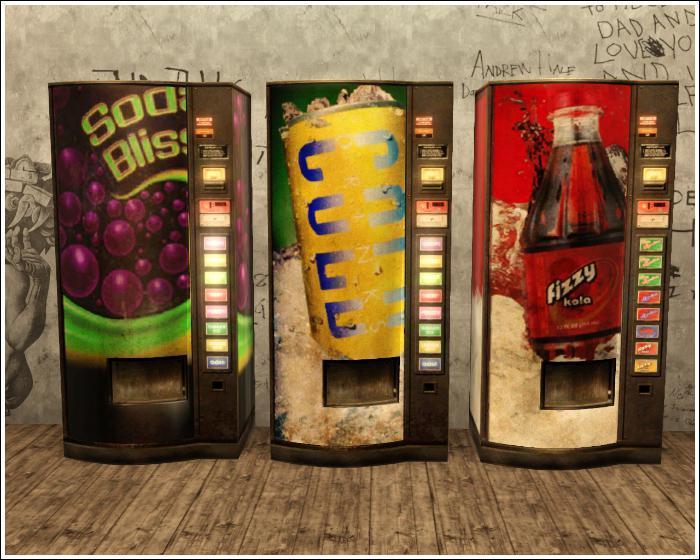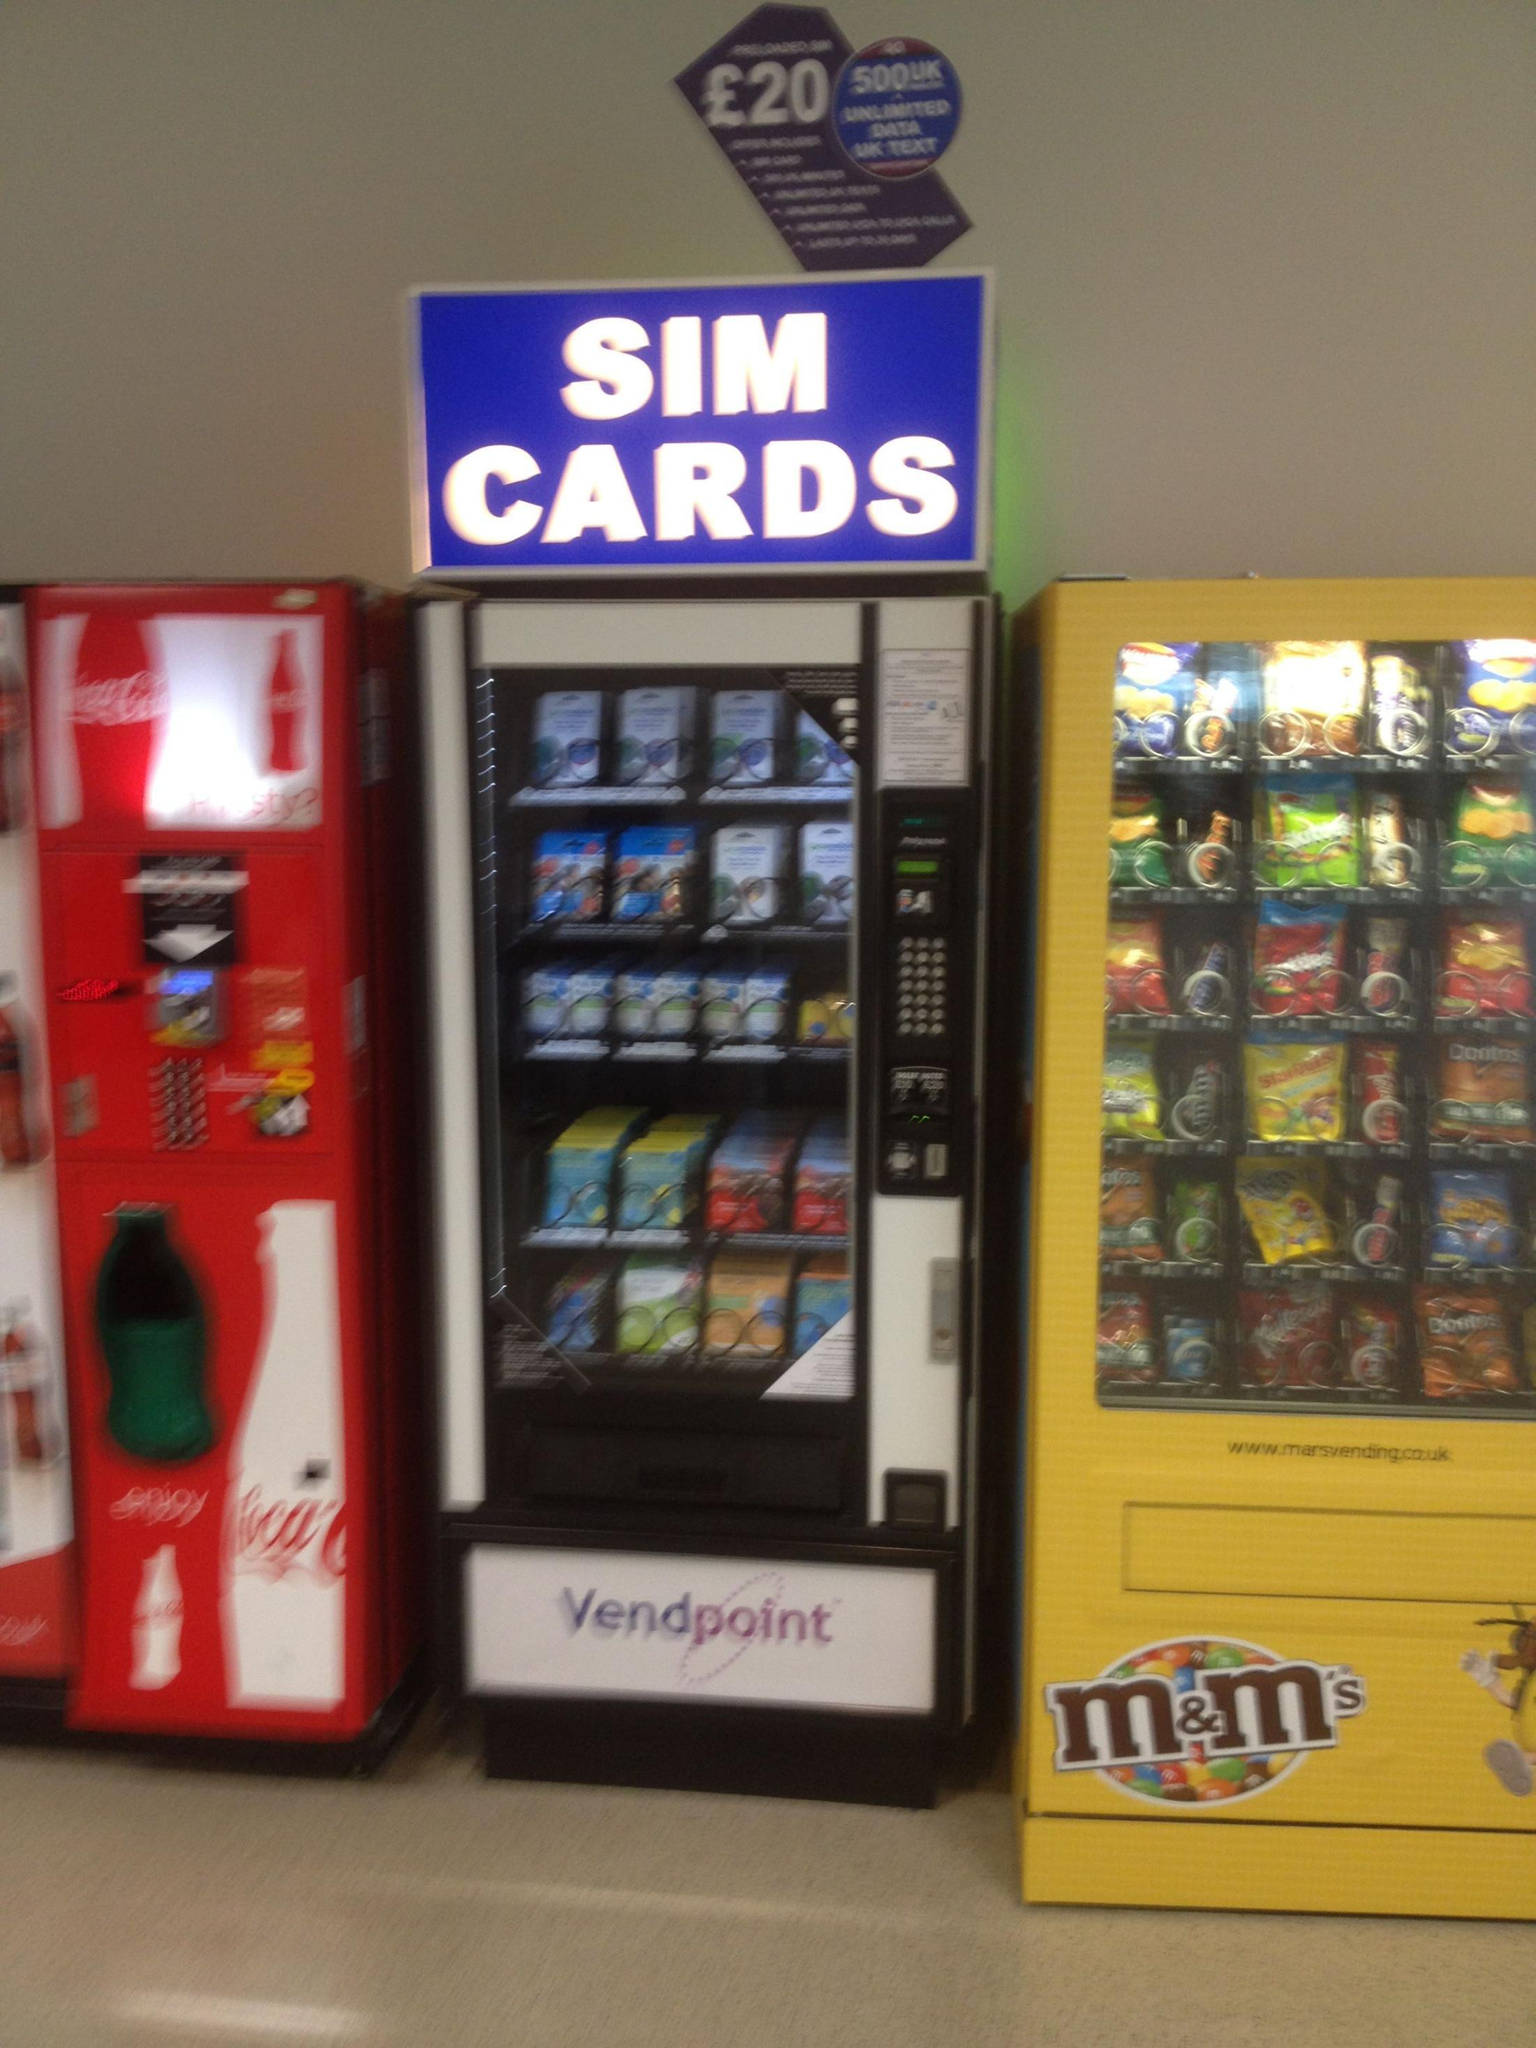The first image is the image on the left, the second image is the image on the right. Examine the images to the left and right. Is the description "Multiple vending machines are displayed in front of a wall of graffiti, in one image." accurate? Answer yes or no. Yes. The first image is the image on the left, the second image is the image on the right. Assess this claim about the two images: "Exactly five vending machines are depicted.". Correct or not? Answer yes or no. No. 